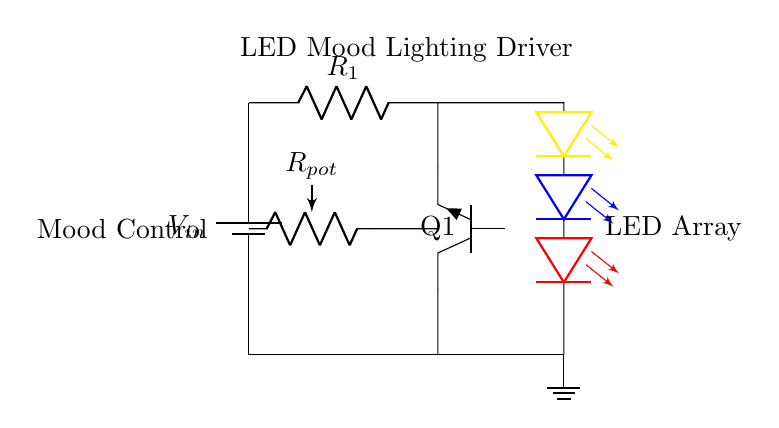What is the type of transistor used in this circuit? The circuit diagram indicates that an NPN transistor is used, which is denoted by the label Q1 in the diagram.
Answer: NPN What is the purpose of the potentiometer in this circuit? The potentiometer, labeled Rpot, is used for mood control, allowing users to adjust the brightness or color of the LED lights by varying the resistance.
Answer: Mood control How many LEDs are in the array? The circuit diagram shows a total of three LEDs represented in the array, specifically colored yellow, blue, and red.
Answer: Three What component is used to limit current to the LEDs? The resistor labeled R1 is the component used to limit current to the LEDs, preventing them from drawing excessive current which could damage them.
Answer: Resistor What is the configuration of the LEDs in the array? The LEDs are connected in parallel as they share the same voltage supply from the power source and can light up independently.
Answer: Parallel Which component provides the input voltage for the circuit? The circuit diagram clearly shows a battery, designated as Vin, providing the input voltage needed to power the entire circuit.
Answer: Battery What type of lighting does this circuit design support? The overall design of the circuit, combined with its components, supports mood lighting, which is suitable for environments like yoga studios where ambiance is important.
Answer: Mood lighting 